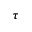<formula> <loc_0><loc_0><loc_500><loc_500>\tau</formula> 